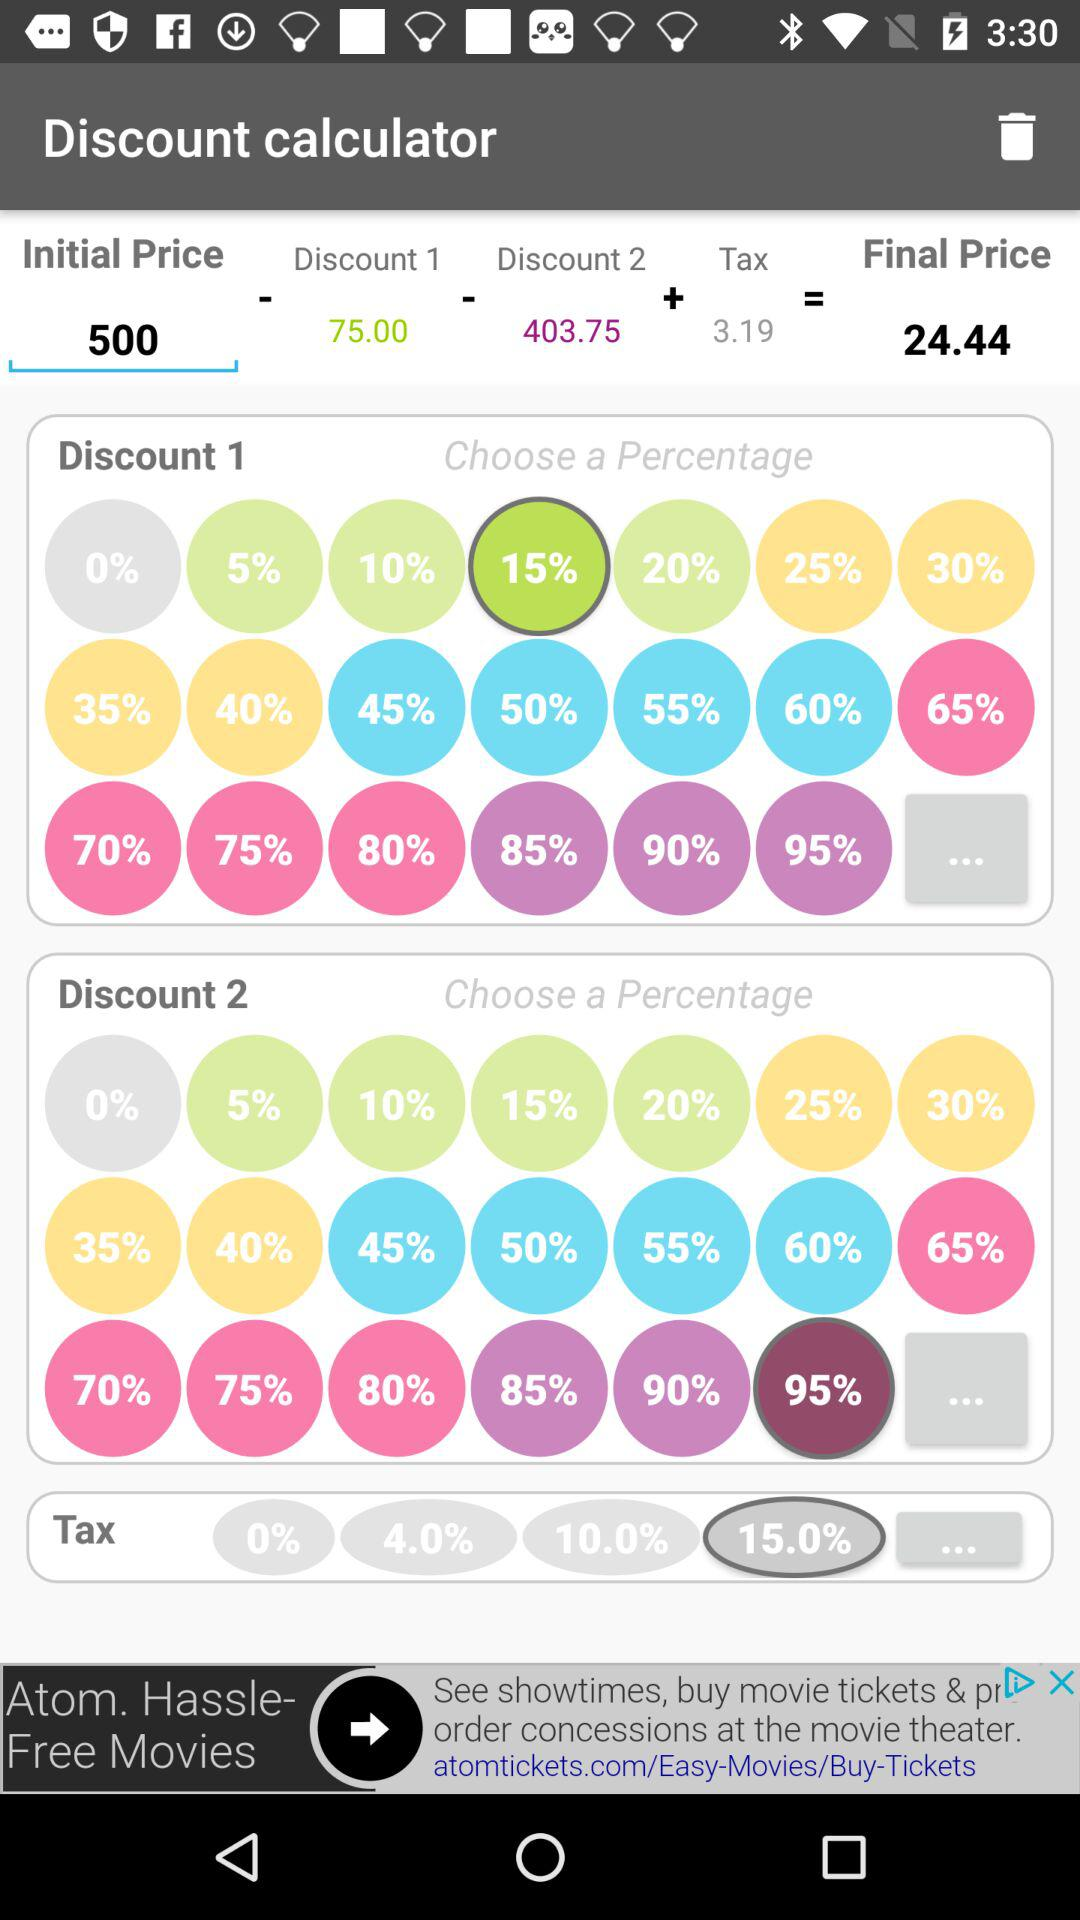What is the value of Discount 2? The value of Discount 2 is 403.75. 